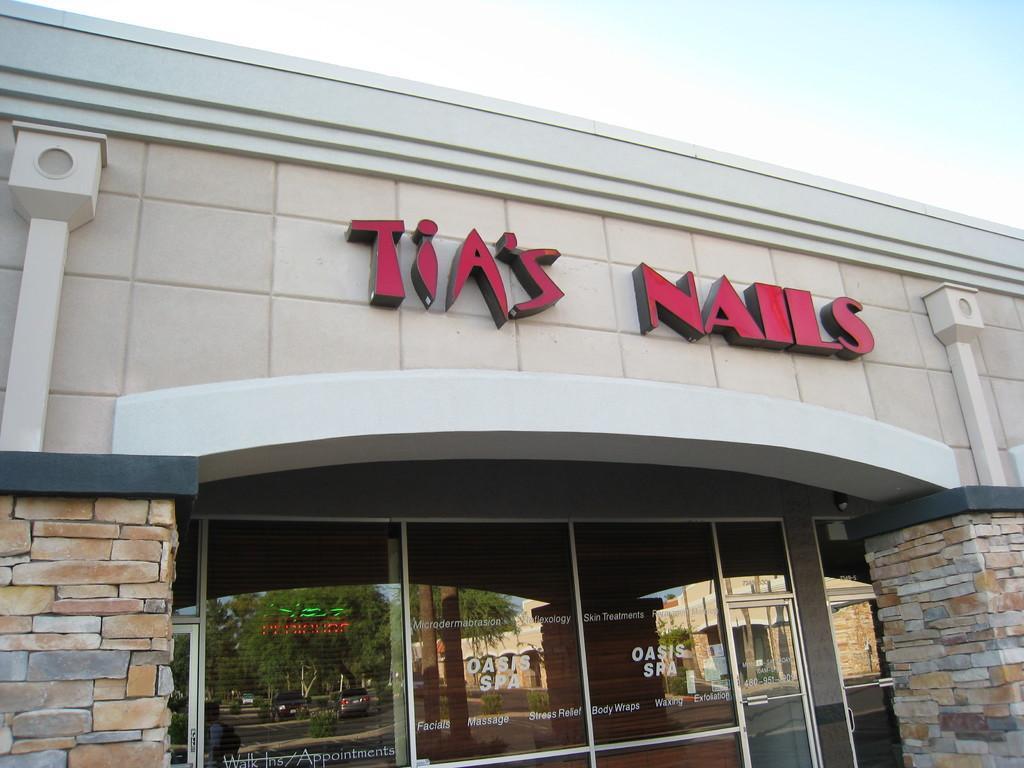How would you summarize this image in a sentence or two? There is a store which has something written on it. 